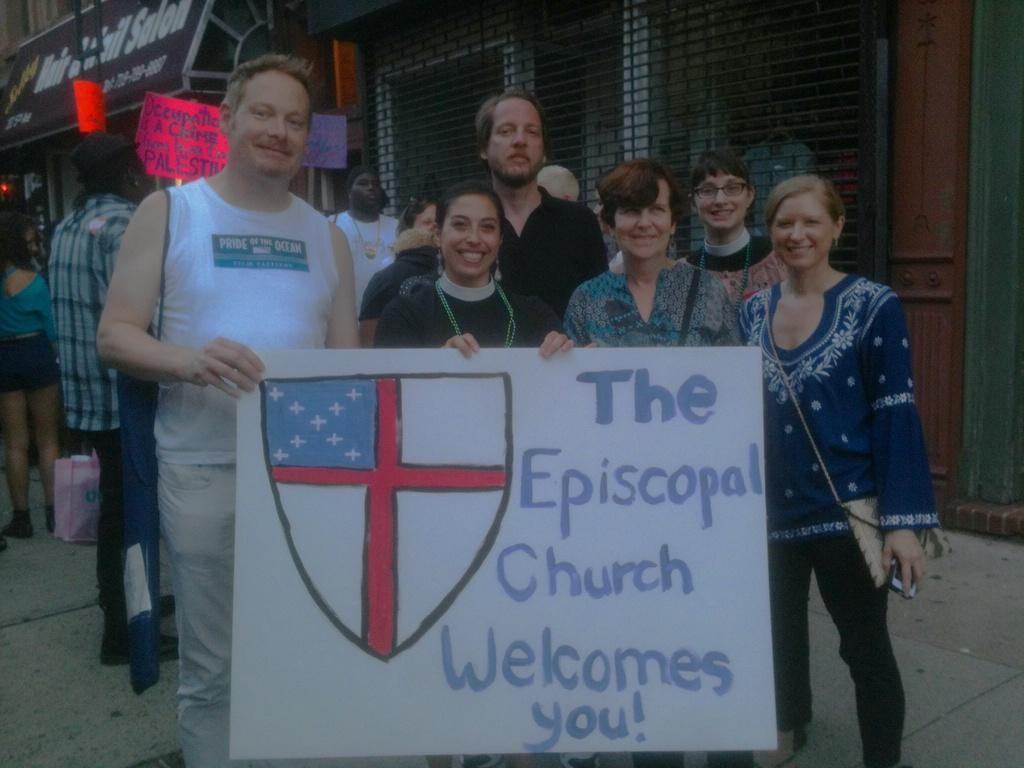How many people are present in the image? There are people in the image, but the exact number is not specified. What are some people doing in the image? Some people are holding objects in the image. What can be seen on the walls in the image? There are posters in the image. What type of establishments can be seen in the image? There are stores in the image. What is a feature of the building in the image? There is a building with windows in the image. What is visible beneath the people and objects in the image? The ground is visible in the image. How many birds can be seen flying through the hole in the image? There are no birds or holes present in the image. 